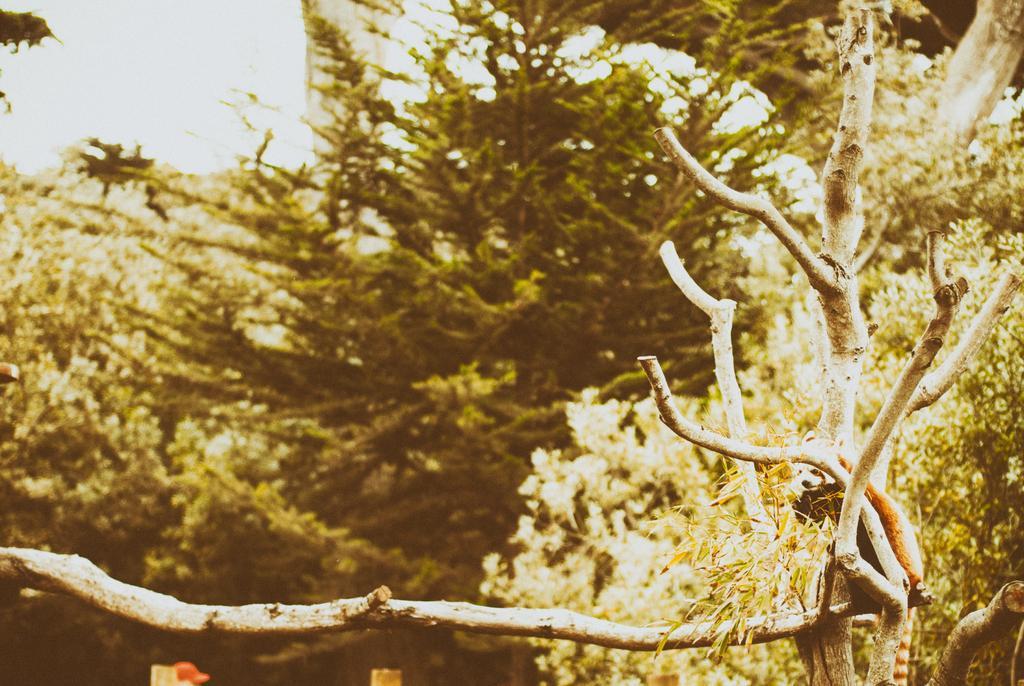Could you give a brief overview of what you see in this image? In this picture we can see an animal on a branch, trees and in the background we can see the sky. 